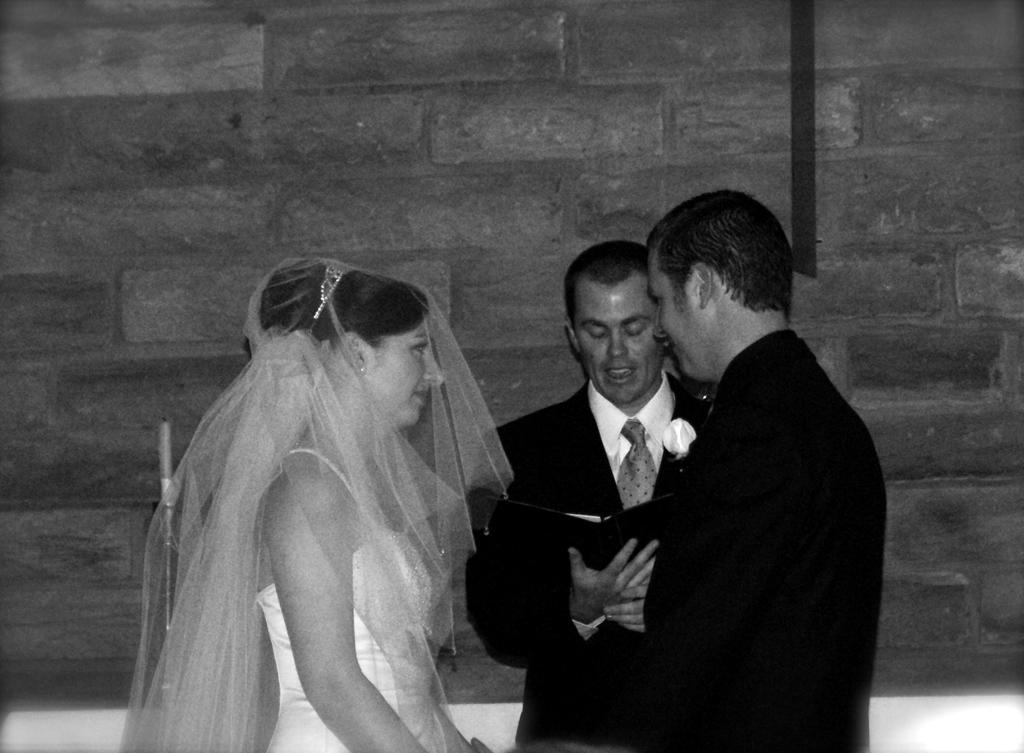In one or two sentences, can you explain what this image depicts? In this picture we can see a tie, book, candle, crown, blazers and three people standing and in the background we can see the wall. 